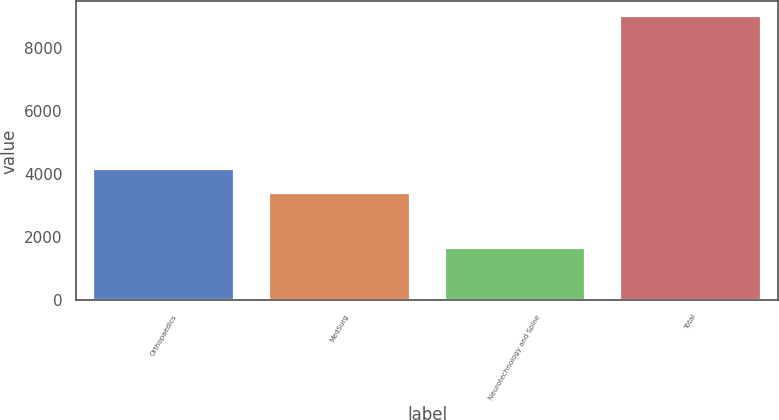Convert chart. <chart><loc_0><loc_0><loc_500><loc_500><bar_chart><fcel>Orthopaedics<fcel>MedSurg<fcel>Neurotechnology and Spine<fcel>Total<nl><fcel>4150.3<fcel>3414<fcel>1658<fcel>9021<nl></chart> 